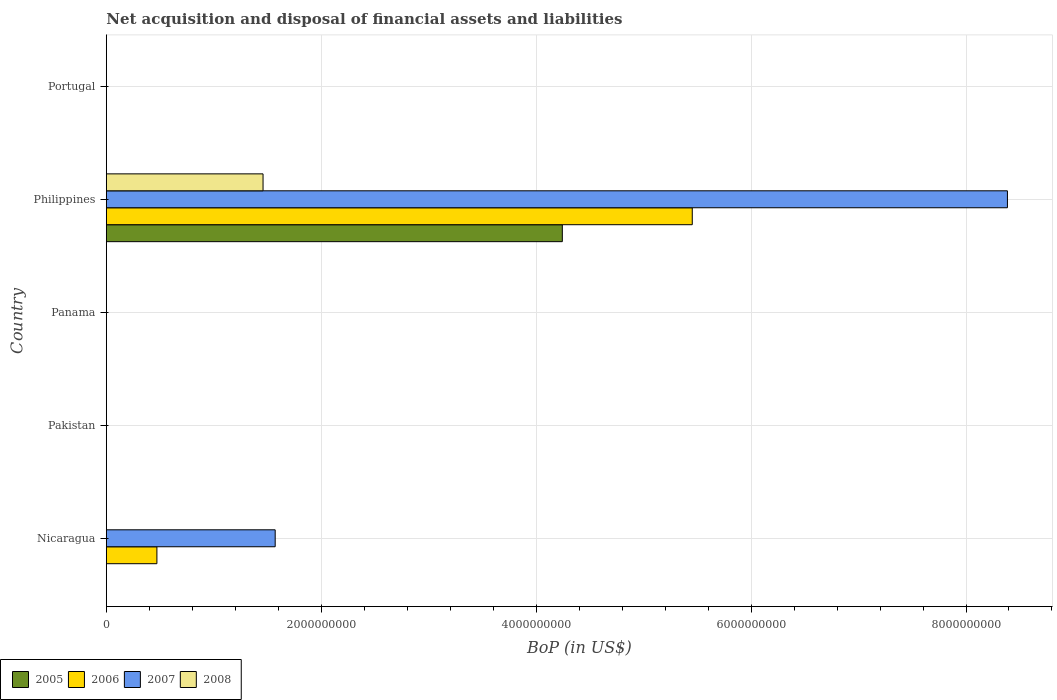Are the number of bars per tick equal to the number of legend labels?
Your answer should be compact. No. How many bars are there on the 1st tick from the top?
Provide a short and direct response. 0. What is the Balance of Payments in 2006 in Panama?
Ensure brevity in your answer.  0. Across all countries, what is the maximum Balance of Payments in 2008?
Offer a very short reply. 1.46e+09. Across all countries, what is the minimum Balance of Payments in 2006?
Offer a terse response. 0. In which country was the Balance of Payments in 2005 maximum?
Your answer should be compact. Philippines. What is the total Balance of Payments in 2005 in the graph?
Your answer should be compact. 4.24e+09. What is the difference between the Balance of Payments in 2007 in Nicaragua and that in Philippines?
Your response must be concise. -6.81e+09. What is the difference between the Balance of Payments in 2008 in Portugal and the Balance of Payments in 2005 in Philippines?
Make the answer very short. -4.24e+09. What is the average Balance of Payments in 2008 per country?
Keep it short and to the point. 2.92e+08. What is the difference between the Balance of Payments in 2008 and Balance of Payments in 2005 in Philippines?
Offer a very short reply. -2.79e+09. What is the ratio of the Balance of Payments in 2007 in Nicaragua to that in Philippines?
Give a very brief answer. 0.19. Is the Balance of Payments in 2006 in Nicaragua less than that in Philippines?
Your answer should be very brief. Yes. What is the difference between the highest and the lowest Balance of Payments in 2008?
Keep it short and to the point. 1.46e+09. Is it the case that in every country, the sum of the Balance of Payments in 2005 and Balance of Payments in 2006 is greater than the sum of Balance of Payments in 2007 and Balance of Payments in 2008?
Make the answer very short. No. Is it the case that in every country, the sum of the Balance of Payments in 2008 and Balance of Payments in 2005 is greater than the Balance of Payments in 2007?
Make the answer very short. No. How many bars are there?
Keep it short and to the point. 6. Are all the bars in the graph horizontal?
Provide a short and direct response. Yes. What is the difference between two consecutive major ticks on the X-axis?
Offer a very short reply. 2.00e+09. Where does the legend appear in the graph?
Your response must be concise. Bottom left. What is the title of the graph?
Provide a succinct answer. Net acquisition and disposal of financial assets and liabilities. Does "2005" appear as one of the legend labels in the graph?
Keep it short and to the point. Yes. What is the label or title of the X-axis?
Give a very brief answer. BoP (in US$). What is the label or title of the Y-axis?
Provide a short and direct response. Country. What is the BoP (in US$) of 2006 in Nicaragua?
Make the answer very short. 4.71e+08. What is the BoP (in US$) of 2007 in Nicaragua?
Provide a succinct answer. 1.57e+09. What is the BoP (in US$) in 2005 in Pakistan?
Ensure brevity in your answer.  0. What is the BoP (in US$) of 2007 in Pakistan?
Your response must be concise. 0. What is the BoP (in US$) in 2005 in Panama?
Provide a short and direct response. 0. What is the BoP (in US$) in 2006 in Panama?
Provide a short and direct response. 0. What is the BoP (in US$) in 2008 in Panama?
Your answer should be compact. 0. What is the BoP (in US$) of 2005 in Philippines?
Give a very brief answer. 4.24e+09. What is the BoP (in US$) of 2006 in Philippines?
Keep it short and to the point. 5.45e+09. What is the BoP (in US$) of 2007 in Philippines?
Ensure brevity in your answer.  8.39e+09. What is the BoP (in US$) in 2008 in Philippines?
Keep it short and to the point. 1.46e+09. What is the BoP (in US$) in 2006 in Portugal?
Give a very brief answer. 0. Across all countries, what is the maximum BoP (in US$) of 2005?
Your response must be concise. 4.24e+09. Across all countries, what is the maximum BoP (in US$) in 2006?
Your response must be concise. 5.45e+09. Across all countries, what is the maximum BoP (in US$) of 2007?
Your response must be concise. 8.39e+09. Across all countries, what is the maximum BoP (in US$) in 2008?
Keep it short and to the point. 1.46e+09. Across all countries, what is the minimum BoP (in US$) in 2007?
Your answer should be compact. 0. What is the total BoP (in US$) in 2005 in the graph?
Your answer should be compact. 4.24e+09. What is the total BoP (in US$) of 2006 in the graph?
Your response must be concise. 5.92e+09. What is the total BoP (in US$) in 2007 in the graph?
Your answer should be compact. 9.96e+09. What is the total BoP (in US$) in 2008 in the graph?
Your response must be concise. 1.46e+09. What is the difference between the BoP (in US$) in 2006 in Nicaragua and that in Philippines?
Your answer should be very brief. -4.98e+09. What is the difference between the BoP (in US$) of 2007 in Nicaragua and that in Philippines?
Provide a succinct answer. -6.81e+09. What is the difference between the BoP (in US$) in 2006 in Nicaragua and the BoP (in US$) in 2007 in Philippines?
Your answer should be very brief. -7.91e+09. What is the difference between the BoP (in US$) of 2006 in Nicaragua and the BoP (in US$) of 2008 in Philippines?
Your answer should be compact. -9.88e+08. What is the difference between the BoP (in US$) of 2007 in Nicaragua and the BoP (in US$) of 2008 in Philippines?
Your response must be concise. 1.13e+08. What is the average BoP (in US$) in 2005 per country?
Ensure brevity in your answer.  8.49e+08. What is the average BoP (in US$) in 2006 per country?
Ensure brevity in your answer.  1.18e+09. What is the average BoP (in US$) in 2007 per country?
Offer a terse response. 1.99e+09. What is the average BoP (in US$) in 2008 per country?
Keep it short and to the point. 2.92e+08. What is the difference between the BoP (in US$) in 2006 and BoP (in US$) in 2007 in Nicaragua?
Your answer should be very brief. -1.10e+09. What is the difference between the BoP (in US$) of 2005 and BoP (in US$) of 2006 in Philippines?
Your response must be concise. -1.21e+09. What is the difference between the BoP (in US$) of 2005 and BoP (in US$) of 2007 in Philippines?
Make the answer very short. -4.14e+09. What is the difference between the BoP (in US$) of 2005 and BoP (in US$) of 2008 in Philippines?
Ensure brevity in your answer.  2.79e+09. What is the difference between the BoP (in US$) in 2006 and BoP (in US$) in 2007 in Philippines?
Provide a short and direct response. -2.93e+09. What is the difference between the BoP (in US$) in 2006 and BoP (in US$) in 2008 in Philippines?
Offer a very short reply. 3.99e+09. What is the difference between the BoP (in US$) in 2007 and BoP (in US$) in 2008 in Philippines?
Your response must be concise. 6.93e+09. What is the ratio of the BoP (in US$) in 2006 in Nicaragua to that in Philippines?
Give a very brief answer. 0.09. What is the ratio of the BoP (in US$) in 2007 in Nicaragua to that in Philippines?
Make the answer very short. 0.19. What is the difference between the highest and the lowest BoP (in US$) in 2005?
Provide a succinct answer. 4.24e+09. What is the difference between the highest and the lowest BoP (in US$) of 2006?
Provide a short and direct response. 5.45e+09. What is the difference between the highest and the lowest BoP (in US$) of 2007?
Ensure brevity in your answer.  8.39e+09. What is the difference between the highest and the lowest BoP (in US$) in 2008?
Make the answer very short. 1.46e+09. 